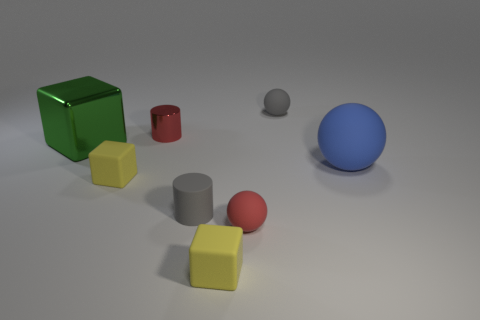Is there an odd one out among these objects, and if so, why? The green cube stands out as the odd one because it's the only object in a bright, reflective green color. All the other objects are either gray, red, blue, or yellow, and they exhibit a more subdued appearance.  If this was a set from a child's playroom, which object do you think would be most popular? Assuming these belong to a child's playroom, the blue ball might be the most popular due to its vibrant color and potential to roll, providing dynamic play opportunities compared to the static cubes and cylinders. 